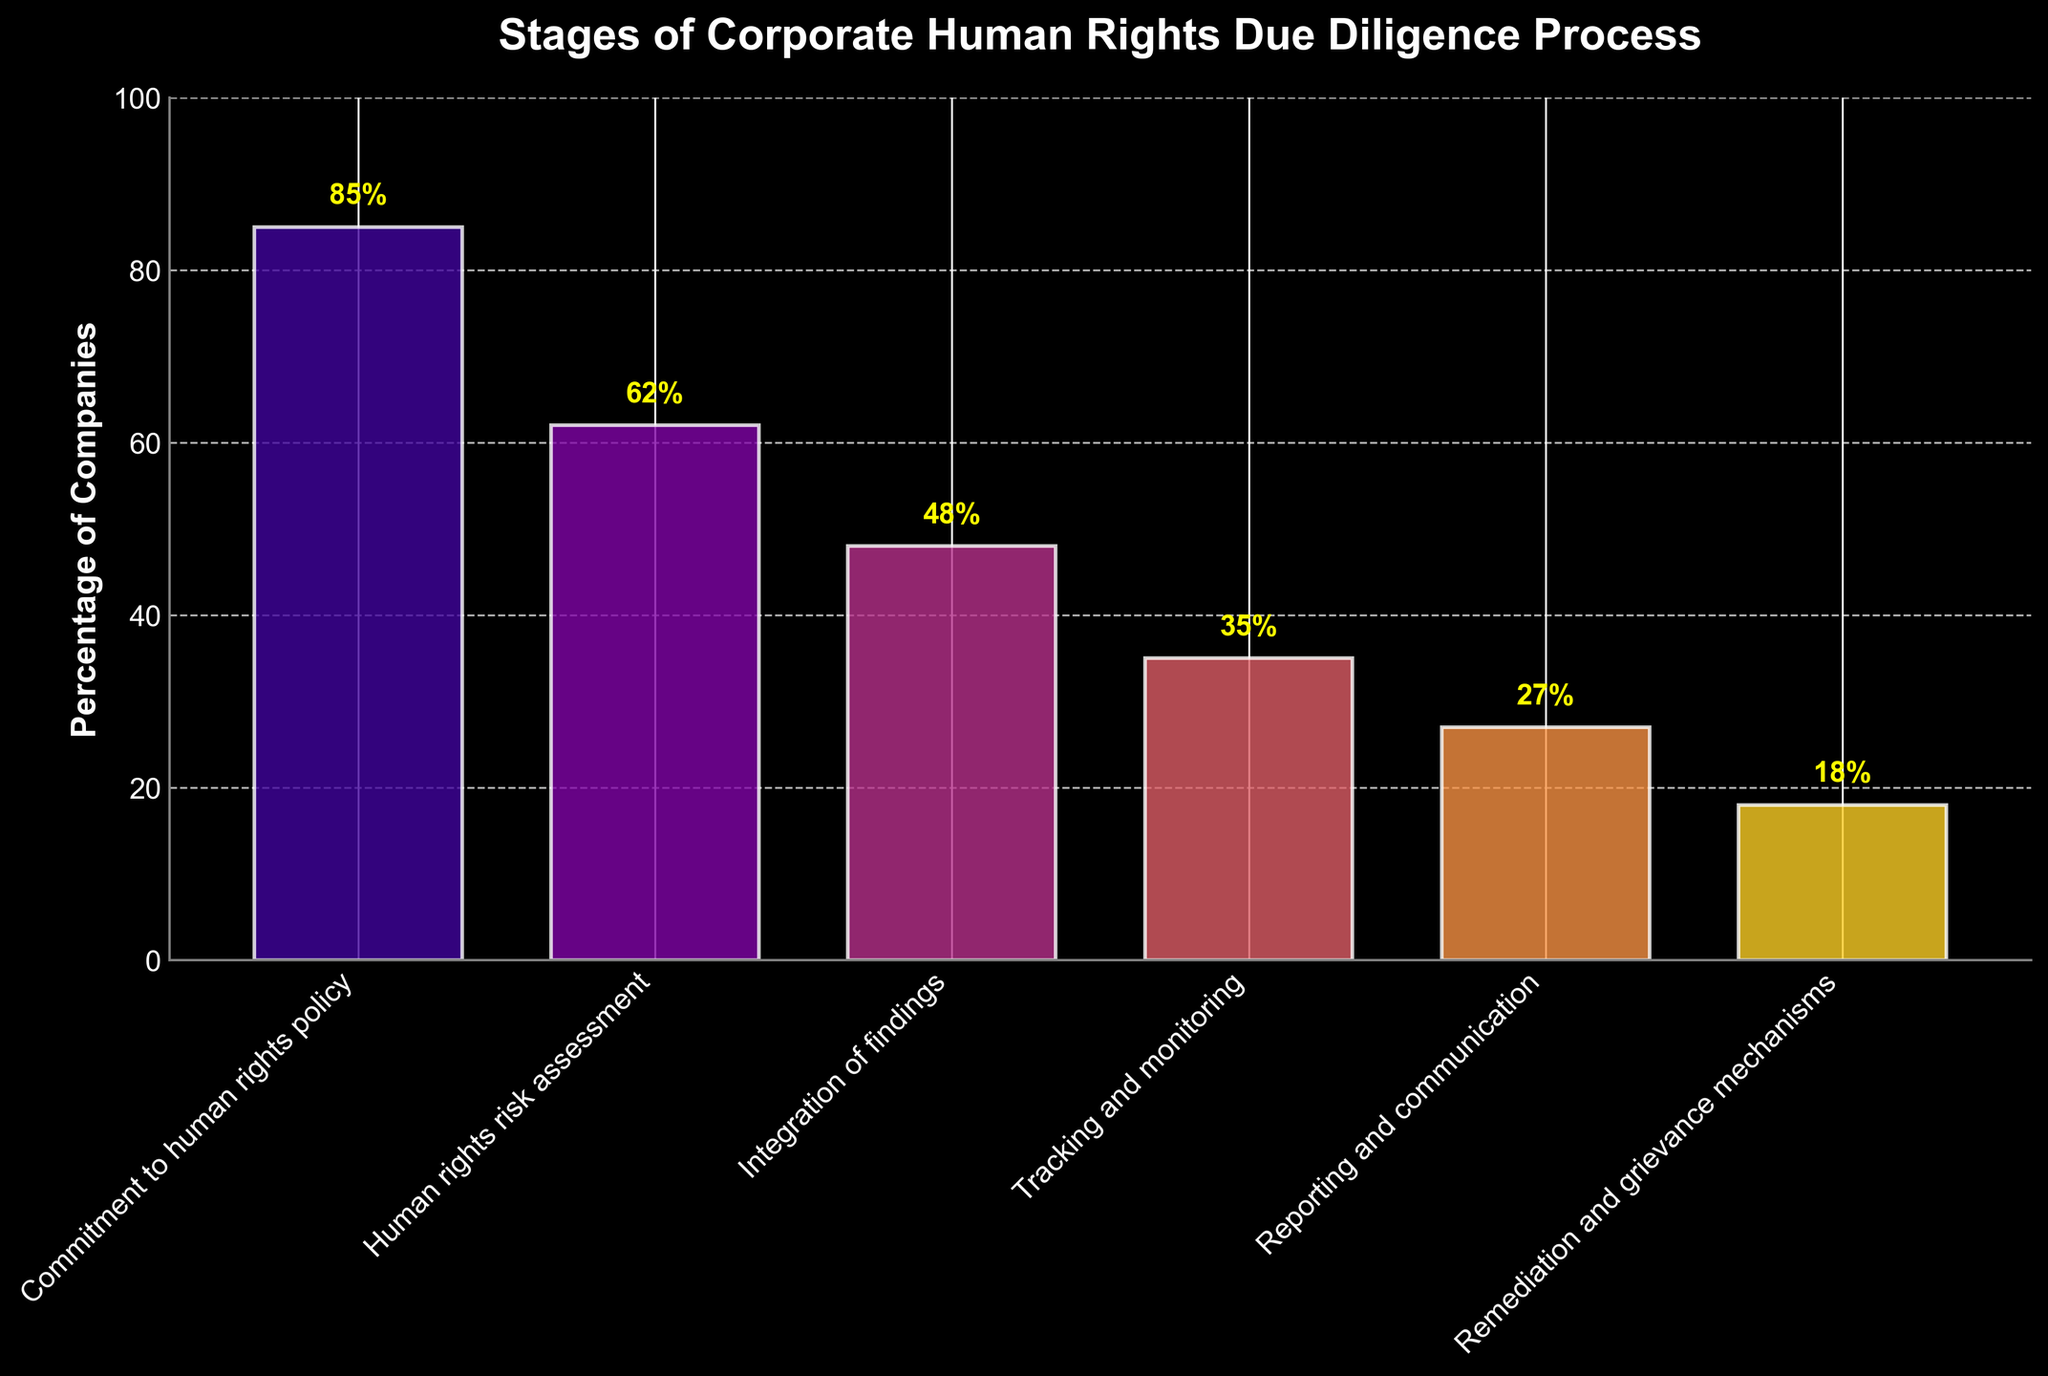What is the title of the figure? The title is located at the top of the figure and is displayed prominently.
Answer: Stages of Corporate Human Rights Due Diligence Process What is the percentage of companies engaged in 'Integration of findings'? Locate the 'Integration of findings' stage on the x-axis and read its corresponding bar height on the y-axis.
Answer: 48% How many stages are depicted in the figure? Count the number of distinct stages along the x-axis.
Answer: 6 What is the difference in percentage between the 'Commitment to human rights policy' stage and the 'Remediation and grievance mechanisms' stage? Find the percentage for both stages on the y-axis and subtract the percentage for 'Remediation and grievance mechanisms' from 'Commitment to human rights policy'. Calculation: 85 - 18 = 67
Answer: 67% Which stage has the smallest percentage of companies involved? Identify the shortest bar in the figure and refer to its label on the x-axis.
Answer: Remediation and grievance mechanisms How does the percentage of companies in 'Reporting and communication' compare to 'Integration of findings'? Find the percentages for both stages on the y-axis and compare their values. Reporting and communication = 27%, Integration of findings = 48%. Since 48% > 27%, 'Integration of findings' has a higher percentage.
Answer: Higher What is the average percentage of companies in the three stages with the highest engagement? Identify the three tallest bars and sum their percentages, then divide by 3. Calculation: (85 + 62 + 48) / 3 = 65
Answer: 65% How many stages have less than 50% company engagement? Identify the bars with heights less than 50% and count them.
Answer: 4 Which stage represents a drop of more than 10% in engagement compared to the previous stage? Look for stages where the percentage difference with the stage before it is greater than 10%. Transition from 'Human rights risk assessment' (62%) to 'Integration of findings' (48%) and from 'Integration of findings' (48%) to 'Tracking and monitoring' (35%) stands out. First drop: 62 - 48 = 14, second drop: 48 - 35 = 13, both are more than 10%.
Answer: Integration of findings, Tracking and monitoring What is the combined percentage of companies engaged in 'Tracking and monitoring' and 'Reporting and communication'? Find the percentages of both stages and add them together. Calculation: 35 + 27 = 62
Answer: 62% 